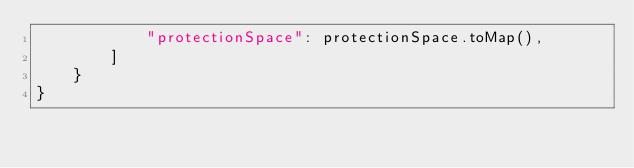Convert code to text. <code><loc_0><loc_0><loc_500><loc_500><_Swift_>            "protectionSpace": protectionSpace.toMap(),
        ]
    }
}
</code> 